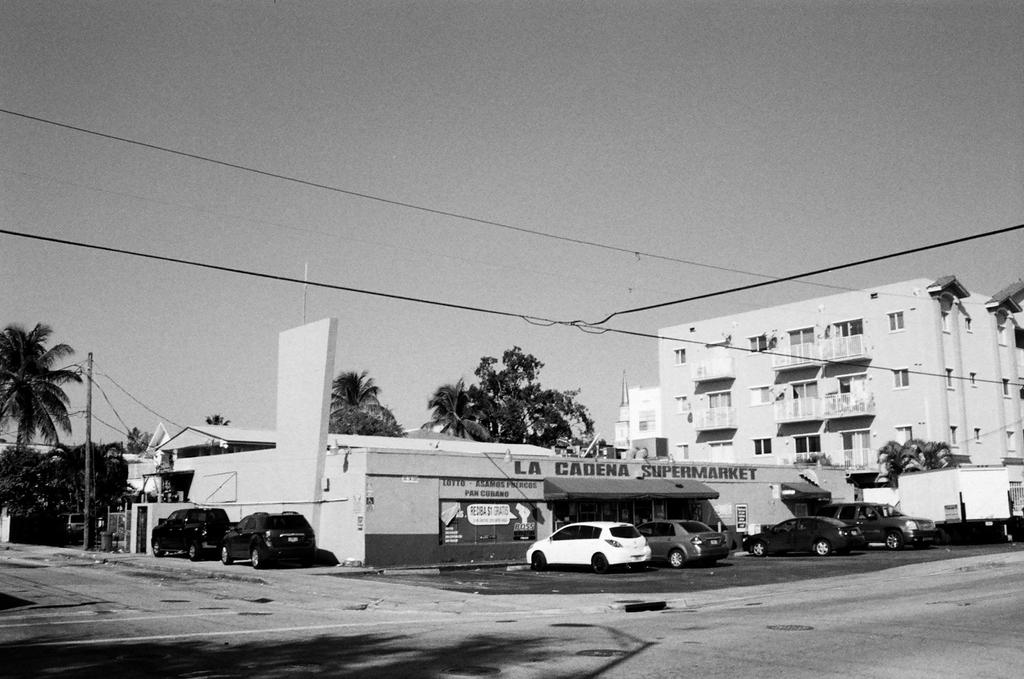What is located in the center of the image? There are buildings in the center of the image. What can be seen at the bottom of the image? There are cars at the bottom of the image. What type of natural elements are visible in the background of the image? There are trees in the background of the image. What else can be seen in the background of the image? There are poles and wires in the background of the image. What is visible in the sky in the background of the image? The sky is visible in the background of the image. Where is the throne located in the image? There is no throne present in the image. Can you describe the type of bat that is flying in the image? There are no bats present in the image. 